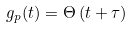<formula> <loc_0><loc_0><loc_500><loc_500>g _ { p } ( t ) = \Theta \left ( t + \tau \right )</formula> 